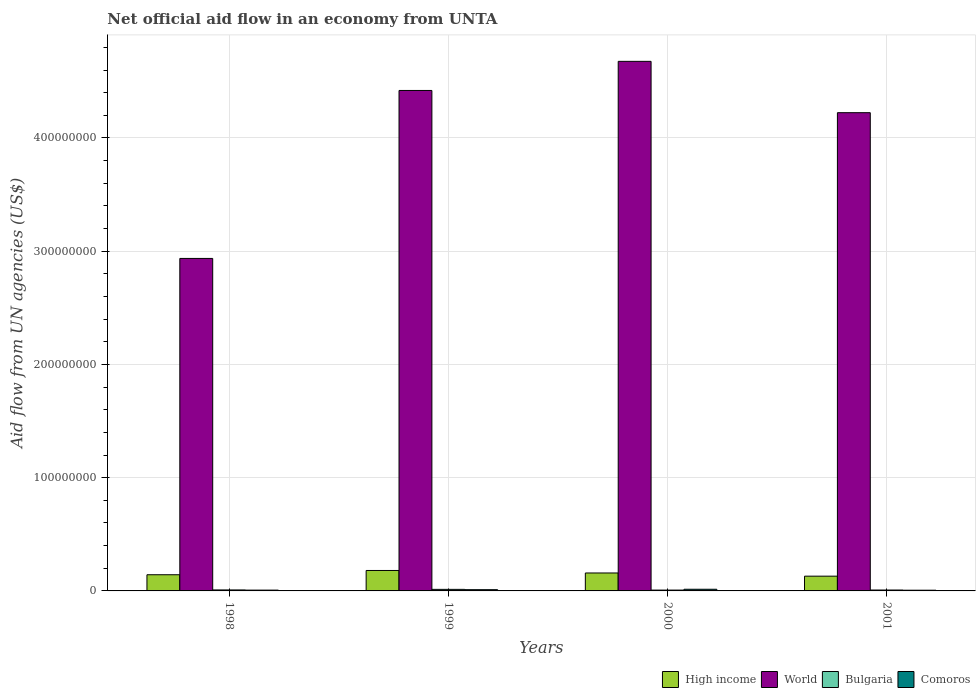Are the number of bars per tick equal to the number of legend labels?
Provide a short and direct response. Yes. What is the label of the 1st group of bars from the left?
Provide a succinct answer. 1998. What is the net official aid flow in High income in 2000?
Make the answer very short. 1.58e+07. Across all years, what is the maximum net official aid flow in World?
Offer a terse response. 4.68e+08. Across all years, what is the minimum net official aid flow in High income?
Provide a short and direct response. 1.30e+07. What is the total net official aid flow in World in the graph?
Provide a short and direct response. 1.63e+09. What is the difference between the net official aid flow in High income in 1999 and that in 2000?
Your answer should be very brief. 2.22e+06. What is the difference between the net official aid flow in Bulgaria in 2001 and the net official aid flow in High income in 1999?
Give a very brief answer. -1.73e+07. What is the average net official aid flow in World per year?
Your answer should be compact. 4.06e+08. In the year 1998, what is the difference between the net official aid flow in Comoros and net official aid flow in High income?
Your answer should be very brief. -1.36e+07. In how many years, is the net official aid flow in Comoros greater than 120000000 US$?
Ensure brevity in your answer.  0. What is the ratio of the net official aid flow in Bulgaria in 1998 to that in 2000?
Make the answer very short. 1.18. Is the net official aid flow in World in 1998 less than that in 2001?
Your response must be concise. Yes. Is the difference between the net official aid flow in Comoros in 1998 and 1999 greater than the difference between the net official aid flow in High income in 1998 and 1999?
Ensure brevity in your answer.  Yes. What is the difference between the highest and the second highest net official aid flow in Comoros?
Your answer should be compact. 3.70e+05. What is the difference between the highest and the lowest net official aid flow in High income?
Your answer should be compact. 5.03e+06. Is the sum of the net official aid flow in Bulgaria in 1998 and 2001 greater than the maximum net official aid flow in World across all years?
Provide a short and direct response. No. Is it the case that in every year, the sum of the net official aid flow in Bulgaria and net official aid flow in World is greater than the sum of net official aid flow in High income and net official aid flow in Comoros?
Your response must be concise. Yes. What does the 2nd bar from the left in 1999 represents?
Ensure brevity in your answer.  World. What does the 2nd bar from the right in 1998 represents?
Provide a short and direct response. Bulgaria. Is it the case that in every year, the sum of the net official aid flow in World and net official aid flow in Comoros is greater than the net official aid flow in High income?
Ensure brevity in your answer.  Yes. Are all the bars in the graph horizontal?
Give a very brief answer. No. Are the values on the major ticks of Y-axis written in scientific E-notation?
Provide a short and direct response. No. Does the graph contain any zero values?
Your answer should be compact. No. Where does the legend appear in the graph?
Offer a very short reply. Bottom right. How many legend labels are there?
Offer a very short reply. 4. What is the title of the graph?
Provide a short and direct response. Net official aid flow in an economy from UNTA. What is the label or title of the X-axis?
Make the answer very short. Years. What is the label or title of the Y-axis?
Keep it short and to the point. Aid flow from UN agencies (US$). What is the Aid flow from UN agencies (US$) of High income in 1998?
Keep it short and to the point. 1.43e+07. What is the Aid flow from UN agencies (US$) of World in 1998?
Provide a succinct answer. 2.94e+08. What is the Aid flow from UN agencies (US$) of Bulgaria in 1998?
Offer a very short reply. 8.70e+05. What is the Aid flow from UN agencies (US$) of Comoros in 1998?
Give a very brief answer. 7.10e+05. What is the Aid flow from UN agencies (US$) in High income in 1999?
Make the answer very short. 1.81e+07. What is the Aid flow from UN agencies (US$) in World in 1999?
Offer a very short reply. 4.42e+08. What is the Aid flow from UN agencies (US$) of Bulgaria in 1999?
Offer a terse response. 1.37e+06. What is the Aid flow from UN agencies (US$) of Comoros in 1999?
Provide a succinct answer. 1.10e+06. What is the Aid flow from UN agencies (US$) of High income in 2000?
Offer a terse response. 1.58e+07. What is the Aid flow from UN agencies (US$) in World in 2000?
Offer a terse response. 4.68e+08. What is the Aid flow from UN agencies (US$) of Bulgaria in 2000?
Provide a short and direct response. 7.40e+05. What is the Aid flow from UN agencies (US$) of Comoros in 2000?
Offer a terse response. 1.47e+06. What is the Aid flow from UN agencies (US$) of High income in 2001?
Provide a short and direct response. 1.30e+07. What is the Aid flow from UN agencies (US$) in World in 2001?
Your response must be concise. 4.22e+08. What is the Aid flow from UN agencies (US$) in Bulgaria in 2001?
Offer a terse response. 7.90e+05. What is the Aid flow from UN agencies (US$) in Comoros in 2001?
Your response must be concise. 6.30e+05. Across all years, what is the maximum Aid flow from UN agencies (US$) of High income?
Ensure brevity in your answer.  1.81e+07. Across all years, what is the maximum Aid flow from UN agencies (US$) of World?
Your answer should be compact. 4.68e+08. Across all years, what is the maximum Aid flow from UN agencies (US$) of Bulgaria?
Offer a terse response. 1.37e+06. Across all years, what is the maximum Aid flow from UN agencies (US$) in Comoros?
Keep it short and to the point. 1.47e+06. Across all years, what is the minimum Aid flow from UN agencies (US$) in High income?
Ensure brevity in your answer.  1.30e+07. Across all years, what is the minimum Aid flow from UN agencies (US$) of World?
Provide a succinct answer. 2.94e+08. Across all years, what is the minimum Aid flow from UN agencies (US$) in Bulgaria?
Provide a short and direct response. 7.40e+05. Across all years, what is the minimum Aid flow from UN agencies (US$) in Comoros?
Make the answer very short. 6.30e+05. What is the total Aid flow from UN agencies (US$) of High income in the graph?
Keep it short and to the point. 6.12e+07. What is the total Aid flow from UN agencies (US$) of World in the graph?
Provide a short and direct response. 1.63e+09. What is the total Aid flow from UN agencies (US$) of Bulgaria in the graph?
Your answer should be compact. 3.77e+06. What is the total Aid flow from UN agencies (US$) in Comoros in the graph?
Your answer should be very brief. 3.91e+06. What is the difference between the Aid flow from UN agencies (US$) of High income in 1998 and that in 1999?
Your answer should be compact. -3.77e+06. What is the difference between the Aid flow from UN agencies (US$) in World in 1998 and that in 1999?
Offer a very short reply. -1.48e+08. What is the difference between the Aid flow from UN agencies (US$) of Bulgaria in 1998 and that in 1999?
Keep it short and to the point. -5.00e+05. What is the difference between the Aid flow from UN agencies (US$) of Comoros in 1998 and that in 1999?
Offer a very short reply. -3.90e+05. What is the difference between the Aid flow from UN agencies (US$) of High income in 1998 and that in 2000?
Ensure brevity in your answer.  -1.55e+06. What is the difference between the Aid flow from UN agencies (US$) in World in 1998 and that in 2000?
Provide a succinct answer. -1.74e+08. What is the difference between the Aid flow from UN agencies (US$) in Bulgaria in 1998 and that in 2000?
Provide a succinct answer. 1.30e+05. What is the difference between the Aid flow from UN agencies (US$) in Comoros in 1998 and that in 2000?
Offer a terse response. -7.60e+05. What is the difference between the Aid flow from UN agencies (US$) in High income in 1998 and that in 2001?
Offer a very short reply. 1.26e+06. What is the difference between the Aid flow from UN agencies (US$) of World in 1998 and that in 2001?
Ensure brevity in your answer.  -1.29e+08. What is the difference between the Aid flow from UN agencies (US$) in Bulgaria in 1998 and that in 2001?
Your response must be concise. 8.00e+04. What is the difference between the Aid flow from UN agencies (US$) in High income in 1999 and that in 2000?
Provide a short and direct response. 2.22e+06. What is the difference between the Aid flow from UN agencies (US$) in World in 1999 and that in 2000?
Make the answer very short. -2.57e+07. What is the difference between the Aid flow from UN agencies (US$) of Bulgaria in 1999 and that in 2000?
Provide a succinct answer. 6.30e+05. What is the difference between the Aid flow from UN agencies (US$) in Comoros in 1999 and that in 2000?
Your answer should be very brief. -3.70e+05. What is the difference between the Aid flow from UN agencies (US$) of High income in 1999 and that in 2001?
Your answer should be compact. 5.03e+06. What is the difference between the Aid flow from UN agencies (US$) of World in 1999 and that in 2001?
Ensure brevity in your answer.  1.96e+07. What is the difference between the Aid flow from UN agencies (US$) of Bulgaria in 1999 and that in 2001?
Provide a succinct answer. 5.80e+05. What is the difference between the Aid flow from UN agencies (US$) in High income in 2000 and that in 2001?
Make the answer very short. 2.81e+06. What is the difference between the Aid flow from UN agencies (US$) in World in 2000 and that in 2001?
Make the answer very short. 4.53e+07. What is the difference between the Aid flow from UN agencies (US$) in Comoros in 2000 and that in 2001?
Keep it short and to the point. 8.40e+05. What is the difference between the Aid flow from UN agencies (US$) of High income in 1998 and the Aid flow from UN agencies (US$) of World in 1999?
Offer a terse response. -4.28e+08. What is the difference between the Aid flow from UN agencies (US$) of High income in 1998 and the Aid flow from UN agencies (US$) of Bulgaria in 1999?
Offer a very short reply. 1.29e+07. What is the difference between the Aid flow from UN agencies (US$) of High income in 1998 and the Aid flow from UN agencies (US$) of Comoros in 1999?
Your answer should be very brief. 1.32e+07. What is the difference between the Aid flow from UN agencies (US$) of World in 1998 and the Aid flow from UN agencies (US$) of Bulgaria in 1999?
Your answer should be compact. 2.92e+08. What is the difference between the Aid flow from UN agencies (US$) of World in 1998 and the Aid flow from UN agencies (US$) of Comoros in 1999?
Your answer should be very brief. 2.93e+08. What is the difference between the Aid flow from UN agencies (US$) of High income in 1998 and the Aid flow from UN agencies (US$) of World in 2000?
Offer a very short reply. -4.53e+08. What is the difference between the Aid flow from UN agencies (US$) of High income in 1998 and the Aid flow from UN agencies (US$) of Bulgaria in 2000?
Your answer should be compact. 1.36e+07. What is the difference between the Aid flow from UN agencies (US$) of High income in 1998 and the Aid flow from UN agencies (US$) of Comoros in 2000?
Your answer should be very brief. 1.28e+07. What is the difference between the Aid flow from UN agencies (US$) in World in 1998 and the Aid flow from UN agencies (US$) in Bulgaria in 2000?
Ensure brevity in your answer.  2.93e+08. What is the difference between the Aid flow from UN agencies (US$) in World in 1998 and the Aid flow from UN agencies (US$) in Comoros in 2000?
Ensure brevity in your answer.  2.92e+08. What is the difference between the Aid flow from UN agencies (US$) in Bulgaria in 1998 and the Aid flow from UN agencies (US$) in Comoros in 2000?
Give a very brief answer. -6.00e+05. What is the difference between the Aid flow from UN agencies (US$) in High income in 1998 and the Aid flow from UN agencies (US$) in World in 2001?
Provide a short and direct response. -4.08e+08. What is the difference between the Aid flow from UN agencies (US$) in High income in 1998 and the Aid flow from UN agencies (US$) in Bulgaria in 2001?
Your response must be concise. 1.35e+07. What is the difference between the Aid flow from UN agencies (US$) in High income in 1998 and the Aid flow from UN agencies (US$) in Comoros in 2001?
Offer a very short reply. 1.37e+07. What is the difference between the Aid flow from UN agencies (US$) of World in 1998 and the Aid flow from UN agencies (US$) of Bulgaria in 2001?
Keep it short and to the point. 2.93e+08. What is the difference between the Aid flow from UN agencies (US$) in World in 1998 and the Aid flow from UN agencies (US$) in Comoros in 2001?
Your answer should be compact. 2.93e+08. What is the difference between the Aid flow from UN agencies (US$) of High income in 1999 and the Aid flow from UN agencies (US$) of World in 2000?
Provide a succinct answer. -4.50e+08. What is the difference between the Aid flow from UN agencies (US$) in High income in 1999 and the Aid flow from UN agencies (US$) in Bulgaria in 2000?
Provide a succinct answer. 1.73e+07. What is the difference between the Aid flow from UN agencies (US$) of High income in 1999 and the Aid flow from UN agencies (US$) of Comoros in 2000?
Offer a very short reply. 1.66e+07. What is the difference between the Aid flow from UN agencies (US$) of World in 1999 and the Aid flow from UN agencies (US$) of Bulgaria in 2000?
Make the answer very short. 4.41e+08. What is the difference between the Aid flow from UN agencies (US$) of World in 1999 and the Aid flow from UN agencies (US$) of Comoros in 2000?
Offer a very short reply. 4.40e+08. What is the difference between the Aid flow from UN agencies (US$) of High income in 1999 and the Aid flow from UN agencies (US$) of World in 2001?
Give a very brief answer. -4.04e+08. What is the difference between the Aid flow from UN agencies (US$) of High income in 1999 and the Aid flow from UN agencies (US$) of Bulgaria in 2001?
Give a very brief answer. 1.73e+07. What is the difference between the Aid flow from UN agencies (US$) of High income in 1999 and the Aid flow from UN agencies (US$) of Comoros in 2001?
Provide a short and direct response. 1.74e+07. What is the difference between the Aid flow from UN agencies (US$) in World in 1999 and the Aid flow from UN agencies (US$) in Bulgaria in 2001?
Your answer should be very brief. 4.41e+08. What is the difference between the Aid flow from UN agencies (US$) of World in 1999 and the Aid flow from UN agencies (US$) of Comoros in 2001?
Provide a succinct answer. 4.41e+08. What is the difference between the Aid flow from UN agencies (US$) of Bulgaria in 1999 and the Aid flow from UN agencies (US$) of Comoros in 2001?
Your response must be concise. 7.40e+05. What is the difference between the Aid flow from UN agencies (US$) in High income in 2000 and the Aid flow from UN agencies (US$) in World in 2001?
Ensure brevity in your answer.  -4.06e+08. What is the difference between the Aid flow from UN agencies (US$) in High income in 2000 and the Aid flow from UN agencies (US$) in Bulgaria in 2001?
Your response must be concise. 1.50e+07. What is the difference between the Aid flow from UN agencies (US$) of High income in 2000 and the Aid flow from UN agencies (US$) of Comoros in 2001?
Your answer should be very brief. 1.52e+07. What is the difference between the Aid flow from UN agencies (US$) in World in 2000 and the Aid flow from UN agencies (US$) in Bulgaria in 2001?
Offer a very short reply. 4.67e+08. What is the difference between the Aid flow from UN agencies (US$) of World in 2000 and the Aid flow from UN agencies (US$) of Comoros in 2001?
Ensure brevity in your answer.  4.67e+08. What is the difference between the Aid flow from UN agencies (US$) of Bulgaria in 2000 and the Aid flow from UN agencies (US$) of Comoros in 2001?
Offer a terse response. 1.10e+05. What is the average Aid flow from UN agencies (US$) of High income per year?
Make the answer very short. 1.53e+07. What is the average Aid flow from UN agencies (US$) of World per year?
Your answer should be compact. 4.06e+08. What is the average Aid flow from UN agencies (US$) of Bulgaria per year?
Your response must be concise. 9.42e+05. What is the average Aid flow from UN agencies (US$) in Comoros per year?
Provide a succinct answer. 9.78e+05. In the year 1998, what is the difference between the Aid flow from UN agencies (US$) in High income and Aid flow from UN agencies (US$) in World?
Ensure brevity in your answer.  -2.79e+08. In the year 1998, what is the difference between the Aid flow from UN agencies (US$) in High income and Aid flow from UN agencies (US$) in Bulgaria?
Give a very brief answer. 1.34e+07. In the year 1998, what is the difference between the Aid flow from UN agencies (US$) of High income and Aid flow from UN agencies (US$) of Comoros?
Ensure brevity in your answer.  1.36e+07. In the year 1998, what is the difference between the Aid flow from UN agencies (US$) in World and Aid flow from UN agencies (US$) in Bulgaria?
Your answer should be compact. 2.93e+08. In the year 1998, what is the difference between the Aid flow from UN agencies (US$) in World and Aid flow from UN agencies (US$) in Comoros?
Give a very brief answer. 2.93e+08. In the year 1999, what is the difference between the Aid flow from UN agencies (US$) in High income and Aid flow from UN agencies (US$) in World?
Offer a very short reply. -4.24e+08. In the year 1999, what is the difference between the Aid flow from UN agencies (US$) in High income and Aid flow from UN agencies (US$) in Bulgaria?
Make the answer very short. 1.67e+07. In the year 1999, what is the difference between the Aid flow from UN agencies (US$) of High income and Aid flow from UN agencies (US$) of Comoros?
Make the answer very short. 1.70e+07. In the year 1999, what is the difference between the Aid flow from UN agencies (US$) of World and Aid flow from UN agencies (US$) of Bulgaria?
Your answer should be very brief. 4.41e+08. In the year 1999, what is the difference between the Aid flow from UN agencies (US$) of World and Aid flow from UN agencies (US$) of Comoros?
Your answer should be compact. 4.41e+08. In the year 2000, what is the difference between the Aid flow from UN agencies (US$) of High income and Aid flow from UN agencies (US$) of World?
Your answer should be very brief. -4.52e+08. In the year 2000, what is the difference between the Aid flow from UN agencies (US$) in High income and Aid flow from UN agencies (US$) in Bulgaria?
Provide a succinct answer. 1.51e+07. In the year 2000, what is the difference between the Aid flow from UN agencies (US$) in High income and Aid flow from UN agencies (US$) in Comoros?
Offer a terse response. 1.44e+07. In the year 2000, what is the difference between the Aid flow from UN agencies (US$) of World and Aid flow from UN agencies (US$) of Bulgaria?
Offer a very short reply. 4.67e+08. In the year 2000, what is the difference between the Aid flow from UN agencies (US$) of World and Aid flow from UN agencies (US$) of Comoros?
Provide a short and direct response. 4.66e+08. In the year 2000, what is the difference between the Aid flow from UN agencies (US$) of Bulgaria and Aid flow from UN agencies (US$) of Comoros?
Your response must be concise. -7.30e+05. In the year 2001, what is the difference between the Aid flow from UN agencies (US$) in High income and Aid flow from UN agencies (US$) in World?
Keep it short and to the point. -4.09e+08. In the year 2001, what is the difference between the Aid flow from UN agencies (US$) of High income and Aid flow from UN agencies (US$) of Bulgaria?
Your response must be concise. 1.22e+07. In the year 2001, what is the difference between the Aid flow from UN agencies (US$) in High income and Aid flow from UN agencies (US$) in Comoros?
Your answer should be compact. 1.24e+07. In the year 2001, what is the difference between the Aid flow from UN agencies (US$) in World and Aid flow from UN agencies (US$) in Bulgaria?
Your answer should be very brief. 4.22e+08. In the year 2001, what is the difference between the Aid flow from UN agencies (US$) of World and Aid flow from UN agencies (US$) of Comoros?
Your answer should be very brief. 4.22e+08. In the year 2001, what is the difference between the Aid flow from UN agencies (US$) of Bulgaria and Aid flow from UN agencies (US$) of Comoros?
Your response must be concise. 1.60e+05. What is the ratio of the Aid flow from UN agencies (US$) in High income in 1998 to that in 1999?
Your answer should be compact. 0.79. What is the ratio of the Aid flow from UN agencies (US$) of World in 1998 to that in 1999?
Your response must be concise. 0.66. What is the ratio of the Aid flow from UN agencies (US$) of Bulgaria in 1998 to that in 1999?
Provide a succinct answer. 0.64. What is the ratio of the Aid flow from UN agencies (US$) in Comoros in 1998 to that in 1999?
Keep it short and to the point. 0.65. What is the ratio of the Aid flow from UN agencies (US$) in High income in 1998 to that in 2000?
Keep it short and to the point. 0.9. What is the ratio of the Aid flow from UN agencies (US$) in World in 1998 to that in 2000?
Give a very brief answer. 0.63. What is the ratio of the Aid flow from UN agencies (US$) in Bulgaria in 1998 to that in 2000?
Your answer should be very brief. 1.18. What is the ratio of the Aid flow from UN agencies (US$) in Comoros in 1998 to that in 2000?
Your response must be concise. 0.48. What is the ratio of the Aid flow from UN agencies (US$) of High income in 1998 to that in 2001?
Ensure brevity in your answer.  1.1. What is the ratio of the Aid flow from UN agencies (US$) of World in 1998 to that in 2001?
Offer a terse response. 0.7. What is the ratio of the Aid flow from UN agencies (US$) of Bulgaria in 1998 to that in 2001?
Provide a short and direct response. 1.1. What is the ratio of the Aid flow from UN agencies (US$) of Comoros in 1998 to that in 2001?
Offer a very short reply. 1.13. What is the ratio of the Aid flow from UN agencies (US$) of High income in 1999 to that in 2000?
Your response must be concise. 1.14. What is the ratio of the Aid flow from UN agencies (US$) in World in 1999 to that in 2000?
Make the answer very short. 0.94. What is the ratio of the Aid flow from UN agencies (US$) in Bulgaria in 1999 to that in 2000?
Your answer should be compact. 1.85. What is the ratio of the Aid flow from UN agencies (US$) of Comoros in 1999 to that in 2000?
Provide a succinct answer. 0.75. What is the ratio of the Aid flow from UN agencies (US$) of High income in 1999 to that in 2001?
Make the answer very short. 1.39. What is the ratio of the Aid flow from UN agencies (US$) of World in 1999 to that in 2001?
Give a very brief answer. 1.05. What is the ratio of the Aid flow from UN agencies (US$) of Bulgaria in 1999 to that in 2001?
Make the answer very short. 1.73. What is the ratio of the Aid flow from UN agencies (US$) in Comoros in 1999 to that in 2001?
Keep it short and to the point. 1.75. What is the ratio of the Aid flow from UN agencies (US$) of High income in 2000 to that in 2001?
Your response must be concise. 1.22. What is the ratio of the Aid flow from UN agencies (US$) in World in 2000 to that in 2001?
Give a very brief answer. 1.11. What is the ratio of the Aid flow from UN agencies (US$) in Bulgaria in 2000 to that in 2001?
Make the answer very short. 0.94. What is the ratio of the Aid flow from UN agencies (US$) in Comoros in 2000 to that in 2001?
Provide a short and direct response. 2.33. What is the difference between the highest and the second highest Aid flow from UN agencies (US$) in High income?
Provide a succinct answer. 2.22e+06. What is the difference between the highest and the second highest Aid flow from UN agencies (US$) in World?
Offer a terse response. 2.57e+07. What is the difference between the highest and the second highest Aid flow from UN agencies (US$) in Bulgaria?
Provide a short and direct response. 5.00e+05. What is the difference between the highest and the second highest Aid flow from UN agencies (US$) in Comoros?
Offer a very short reply. 3.70e+05. What is the difference between the highest and the lowest Aid flow from UN agencies (US$) in High income?
Your response must be concise. 5.03e+06. What is the difference between the highest and the lowest Aid flow from UN agencies (US$) of World?
Provide a short and direct response. 1.74e+08. What is the difference between the highest and the lowest Aid flow from UN agencies (US$) in Bulgaria?
Offer a terse response. 6.30e+05. What is the difference between the highest and the lowest Aid flow from UN agencies (US$) in Comoros?
Your answer should be very brief. 8.40e+05. 